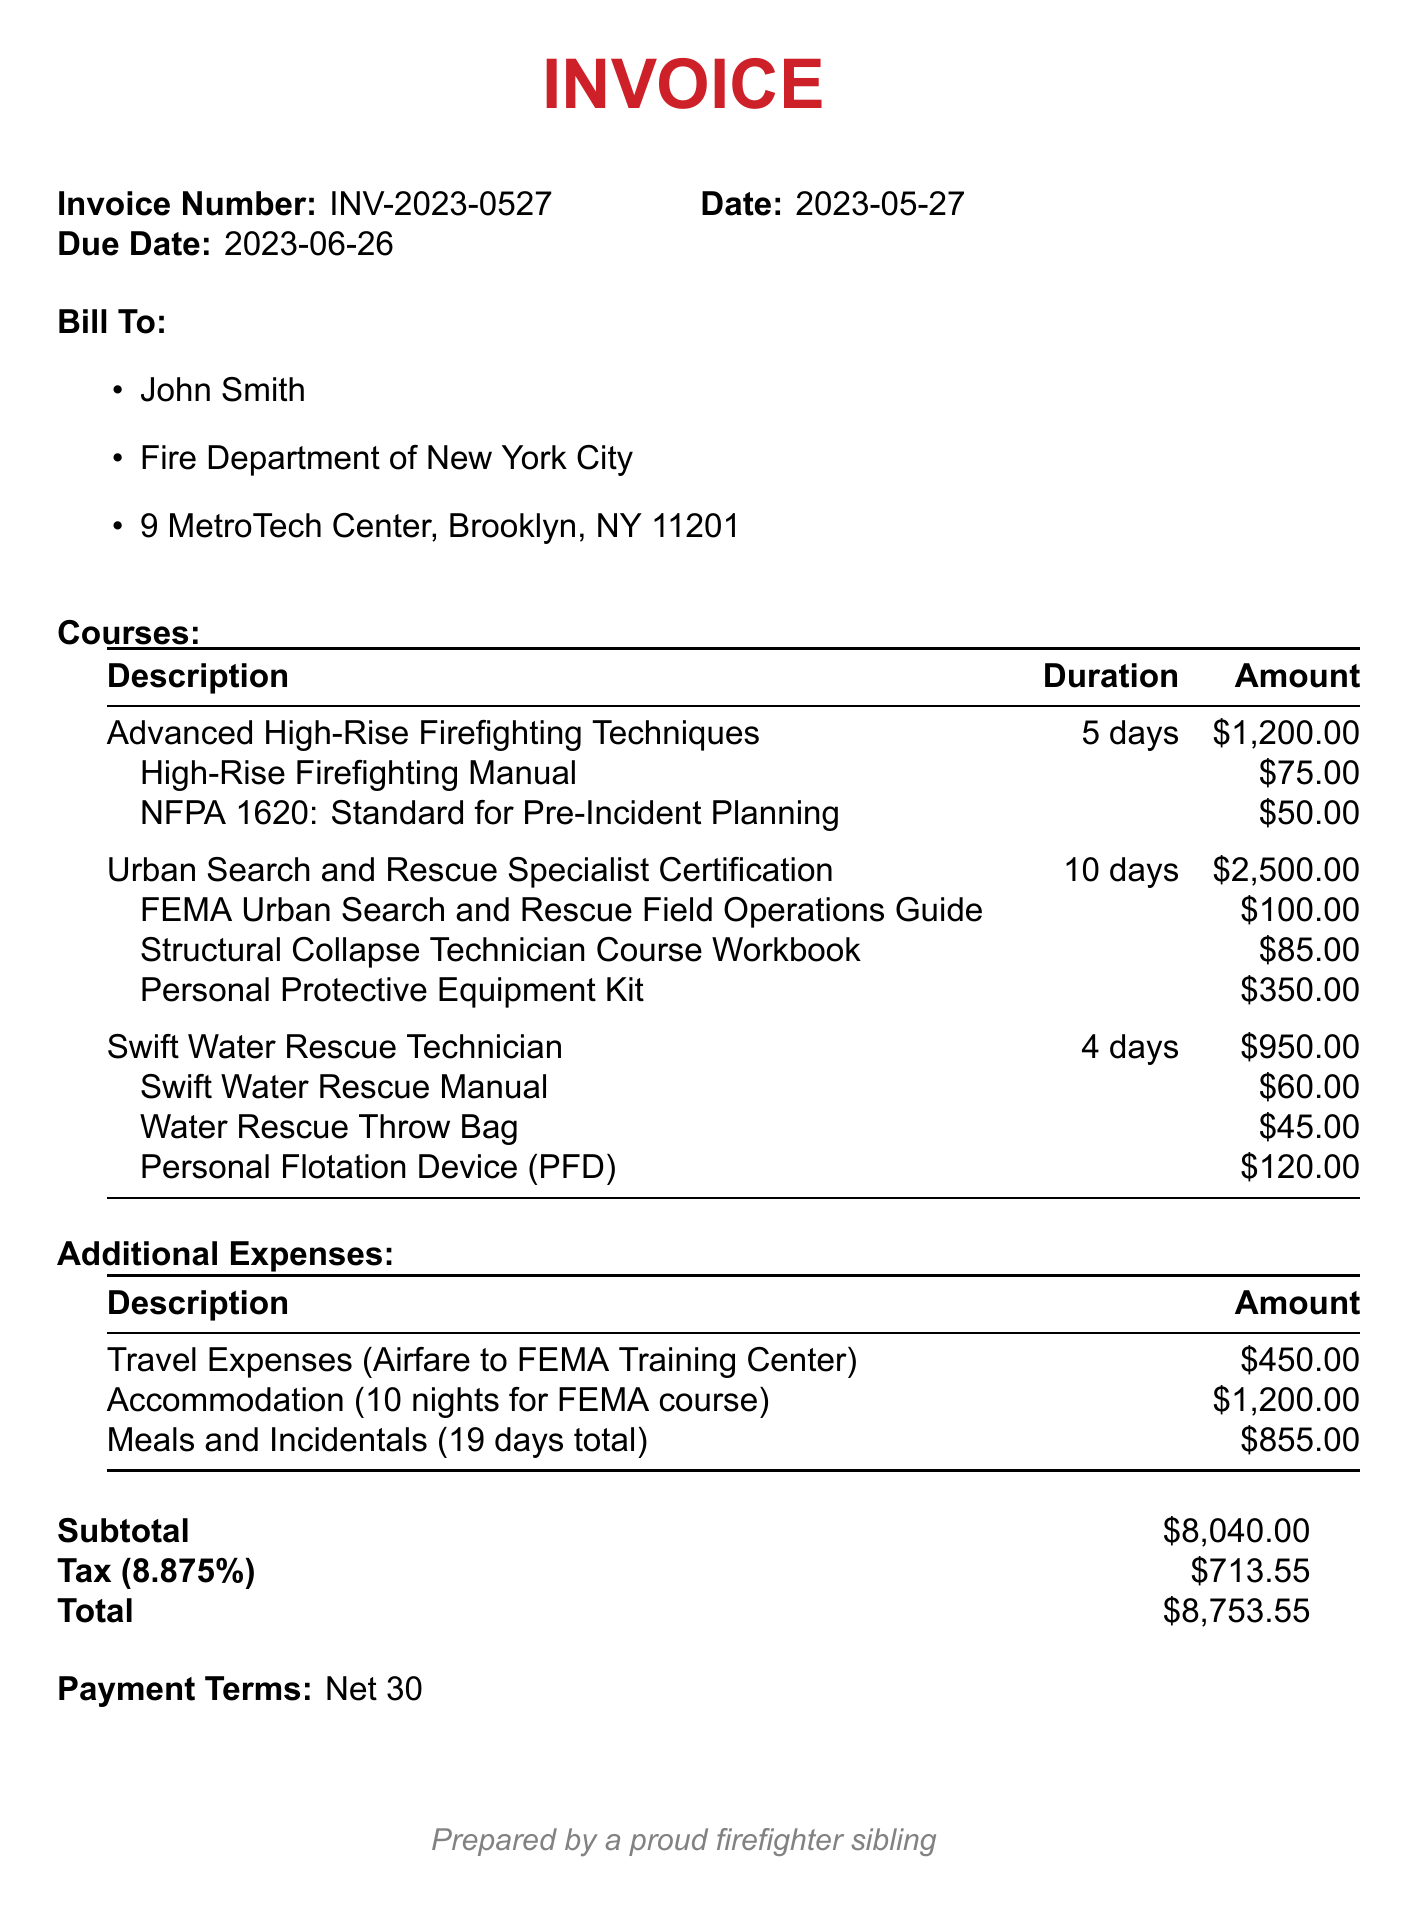What is the invoice number? The invoice number is a unique identifier for the document, which is found at the top of the invoice.
Answer: INV-2023-0527 Who is the bill recipient? The bill recipient's name and department can be found in the "Bill To" section of the invoice.
Answer: John Smith What is the due date for payment? The due date is indicated in the invoice and refers to when payment must be made.
Answer: 2023-06-26 How many courses are listed in the invoice? The number of courses is determined by counting the entries in the "Courses" section.
Answer: 3 What is the total amount due? The total amount is the final figure summed from the subtotal, tax, and any additional expenses listed at the end.
Answer: 8753.55 What is the duration of the "Advanced High-Rise Firefighting Techniques" course? The duration is specified next to the course title in the "Courses" section.
Answer: 5 days What is the tax rate applied to this invoice? The tax rate is noted in the "Tax" line of the final summary.
Answer: 8.875% How much was spent on meals and incidentals? The expense for meals and incidentals is found under the "Additional Expenses" section.
Answer: 855 What is the payment terms indicated in the invoice? The payment terms are specified to inform when payment is expected.
Answer: Net 30 